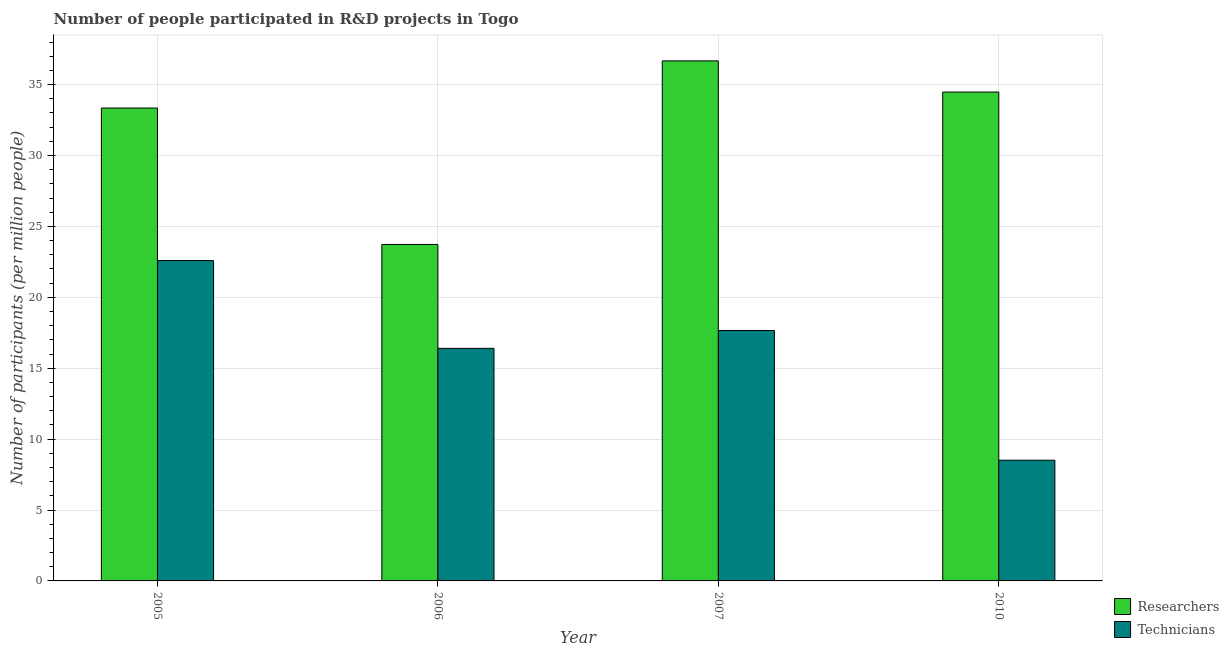How many different coloured bars are there?
Your answer should be compact. 2. How many bars are there on the 3rd tick from the right?
Offer a very short reply. 2. What is the label of the 2nd group of bars from the left?
Offer a very short reply. 2006. What is the number of researchers in 2005?
Your answer should be compact. 33.34. Across all years, what is the maximum number of researchers?
Offer a very short reply. 36.67. Across all years, what is the minimum number of technicians?
Your response must be concise. 8.51. What is the total number of researchers in the graph?
Your answer should be very brief. 128.21. What is the difference between the number of technicians in 2006 and that in 2007?
Your response must be concise. -1.26. What is the difference between the number of technicians in 2005 and the number of researchers in 2010?
Keep it short and to the point. 14.08. What is the average number of technicians per year?
Offer a terse response. 16.29. In how many years, is the number of researchers greater than 5?
Your answer should be very brief. 4. What is the ratio of the number of researchers in 2005 to that in 2006?
Make the answer very short. 1.41. What is the difference between the highest and the second highest number of technicians?
Provide a succinct answer. 4.93. What is the difference between the highest and the lowest number of technicians?
Offer a very short reply. 14.08. In how many years, is the number of researchers greater than the average number of researchers taken over all years?
Keep it short and to the point. 3. What does the 2nd bar from the left in 2007 represents?
Your response must be concise. Technicians. What does the 1st bar from the right in 2006 represents?
Your response must be concise. Technicians. Are all the bars in the graph horizontal?
Make the answer very short. No. How many years are there in the graph?
Your response must be concise. 4. What is the difference between two consecutive major ticks on the Y-axis?
Provide a short and direct response. 5. Are the values on the major ticks of Y-axis written in scientific E-notation?
Keep it short and to the point. No. Where does the legend appear in the graph?
Ensure brevity in your answer.  Bottom right. What is the title of the graph?
Ensure brevity in your answer.  Number of people participated in R&D projects in Togo. Does "Birth rate" appear as one of the legend labels in the graph?
Your answer should be compact. No. What is the label or title of the Y-axis?
Give a very brief answer. Number of participants (per million people). What is the Number of participants (per million people) in Researchers in 2005?
Ensure brevity in your answer.  33.34. What is the Number of participants (per million people) of Technicians in 2005?
Ensure brevity in your answer.  22.59. What is the Number of participants (per million people) in Researchers in 2006?
Your answer should be compact. 23.73. What is the Number of participants (per million people) in Technicians in 2006?
Provide a succinct answer. 16.4. What is the Number of participants (per million people) of Researchers in 2007?
Your answer should be very brief. 36.67. What is the Number of participants (per million people) in Technicians in 2007?
Provide a short and direct response. 17.66. What is the Number of participants (per million people) of Researchers in 2010?
Provide a succinct answer. 34.47. What is the Number of participants (per million people) of Technicians in 2010?
Provide a succinct answer. 8.51. Across all years, what is the maximum Number of participants (per million people) of Researchers?
Your answer should be very brief. 36.67. Across all years, what is the maximum Number of participants (per million people) in Technicians?
Your answer should be very brief. 22.59. Across all years, what is the minimum Number of participants (per million people) in Researchers?
Ensure brevity in your answer.  23.73. Across all years, what is the minimum Number of participants (per million people) in Technicians?
Provide a succinct answer. 8.51. What is the total Number of participants (per million people) in Researchers in the graph?
Provide a succinct answer. 128.21. What is the total Number of participants (per million people) in Technicians in the graph?
Provide a short and direct response. 65.15. What is the difference between the Number of participants (per million people) of Researchers in 2005 and that in 2006?
Provide a short and direct response. 9.62. What is the difference between the Number of participants (per million people) in Technicians in 2005 and that in 2006?
Provide a short and direct response. 6.19. What is the difference between the Number of participants (per million people) of Researchers in 2005 and that in 2007?
Your answer should be compact. -3.33. What is the difference between the Number of participants (per million people) in Technicians in 2005 and that in 2007?
Offer a very short reply. 4.93. What is the difference between the Number of participants (per million people) of Researchers in 2005 and that in 2010?
Offer a terse response. -1.13. What is the difference between the Number of participants (per million people) of Technicians in 2005 and that in 2010?
Provide a succinct answer. 14.08. What is the difference between the Number of participants (per million people) of Researchers in 2006 and that in 2007?
Keep it short and to the point. -12.94. What is the difference between the Number of participants (per million people) of Technicians in 2006 and that in 2007?
Provide a short and direct response. -1.26. What is the difference between the Number of participants (per million people) in Researchers in 2006 and that in 2010?
Ensure brevity in your answer.  -10.75. What is the difference between the Number of participants (per million people) of Technicians in 2006 and that in 2010?
Your answer should be very brief. 7.89. What is the difference between the Number of participants (per million people) in Researchers in 2007 and that in 2010?
Offer a very short reply. 2.2. What is the difference between the Number of participants (per million people) of Technicians in 2007 and that in 2010?
Provide a succinct answer. 9.14. What is the difference between the Number of participants (per million people) in Researchers in 2005 and the Number of participants (per million people) in Technicians in 2006?
Your response must be concise. 16.95. What is the difference between the Number of participants (per million people) in Researchers in 2005 and the Number of participants (per million people) in Technicians in 2007?
Make the answer very short. 15.69. What is the difference between the Number of participants (per million people) of Researchers in 2005 and the Number of participants (per million people) of Technicians in 2010?
Your response must be concise. 24.83. What is the difference between the Number of participants (per million people) of Researchers in 2006 and the Number of participants (per million people) of Technicians in 2007?
Give a very brief answer. 6.07. What is the difference between the Number of participants (per million people) in Researchers in 2006 and the Number of participants (per million people) in Technicians in 2010?
Your response must be concise. 15.21. What is the difference between the Number of participants (per million people) in Researchers in 2007 and the Number of participants (per million people) in Technicians in 2010?
Make the answer very short. 28.16. What is the average Number of participants (per million people) in Researchers per year?
Offer a terse response. 32.05. What is the average Number of participants (per million people) in Technicians per year?
Your answer should be compact. 16.29. In the year 2005, what is the difference between the Number of participants (per million people) in Researchers and Number of participants (per million people) in Technicians?
Provide a succinct answer. 10.76. In the year 2006, what is the difference between the Number of participants (per million people) in Researchers and Number of participants (per million people) in Technicians?
Offer a terse response. 7.33. In the year 2007, what is the difference between the Number of participants (per million people) in Researchers and Number of participants (per million people) in Technicians?
Offer a terse response. 19.01. In the year 2010, what is the difference between the Number of participants (per million people) in Researchers and Number of participants (per million people) in Technicians?
Provide a succinct answer. 25.96. What is the ratio of the Number of participants (per million people) of Researchers in 2005 to that in 2006?
Ensure brevity in your answer.  1.41. What is the ratio of the Number of participants (per million people) in Technicians in 2005 to that in 2006?
Make the answer very short. 1.38. What is the ratio of the Number of participants (per million people) in Researchers in 2005 to that in 2007?
Offer a very short reply. 0.91. What is the ratio of the Number of participants (per million people) of Technicians in 2005 to that in 2007?
Your response must be concise. 1.28. What is the ratio of the Number of participants (per million people) of Researchers in 2005 to that in 2010?
Offer a very short reply. 0.97. What is the ratio of the Number of participants (per million people) of Technicians in 2005 to that in 2010?
Ensure brevity in your answer.  2.65. What is the ratio of the Number of participants (per million people) of Researchers in 2006 to that in 2007?
Ensure brevity in your answer.  0.65. What is the ratio of the Number of participants (per million people) in Technicians in 2006 to that in 2007?
Offer a very short reply. 0.93. What is the ratio of the Number of participants (per million people) in Researchers in 2006 to that in 2010?
Provide a succinct answer. 0.69. What is the ratio of the Number of participants (per million people) of Technicians in 2006 to that in 2010?
Your answer should be compact. 1.93. What is the ratio of the Number of participants (per million people) of Researchers in 2007 to that in 2010?
Ensure brevity in your answer.  1.06. What is the ratio of the Number of participants (per million people) in Technicians in 2007 to that in 2010?
Keep it short and to the point. 2.07. What is the difference between the highest and the second highest Number of participants (per million people) in Researchers?
Offer a very short reply. 2.2. What is the difference between the highest and the second highest Number of participants (per million people) of Technicians?
Your response must be concise. 4.93. What is the difference between the highest and the lowest Number of participants (per million people) of Researchers?
Offer a terse response. 12.94. What is the difference between the highest and the lowest Number of participants (per million people) in Technicians?
Give a very brief answer. 14.08. 